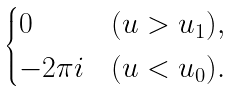Convert formula to latex. <formula><loc_0><loc_0><loc_500><loc_500>\begin{cases} 0 & ( u > u _ { 1 } ) , \\ - 2 \pi i & ( u < u _ { 0 } ) . \end{cases}</formula> 